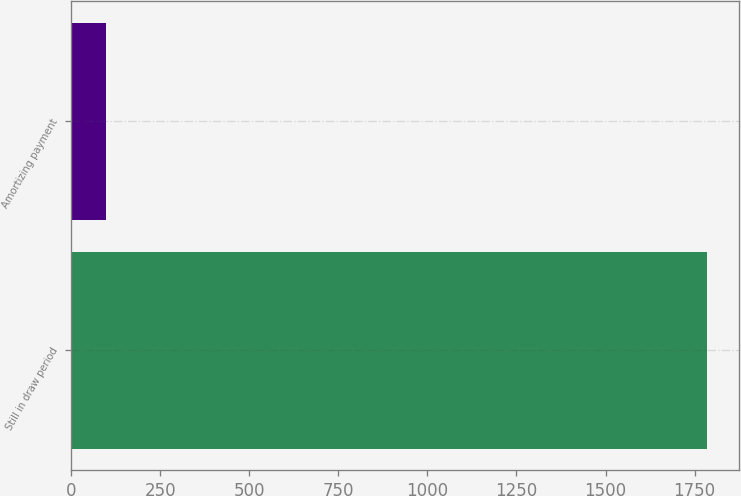Convert chart to OTSL. <chart><loc_0><loc_0><loc_500><loc_500><bar_chart><fcel>Still in draw period<fcel>Amortizing payment<nl><fcel>1784.4<fcel>96.7<nl></chart> 